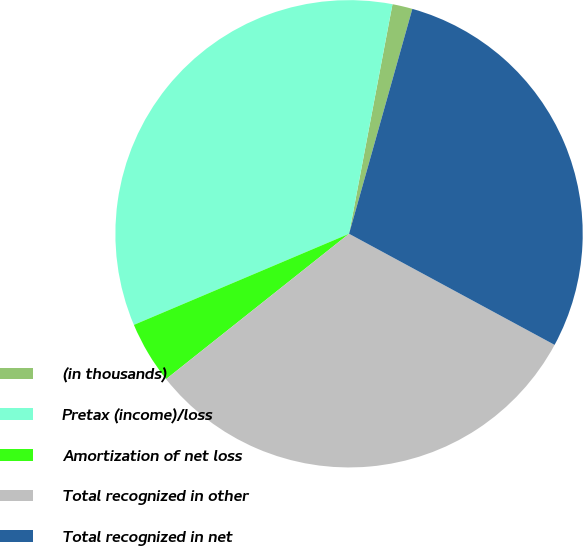Convert chart to OTSL. <chart><loc_0><loc_0><loc_500><loc_500><pie_chart><fcel>(in thousands)<fcel>Pretax (income)/loss<fcel>Amortization of net loss<fcel>Total recognized in other<fcel>Total recognized in net<nl><fcel>1.39%<fcel>34.35%<fcel>4.31%<fcel>31.43%<fcel>28.52%<nl></chart> 